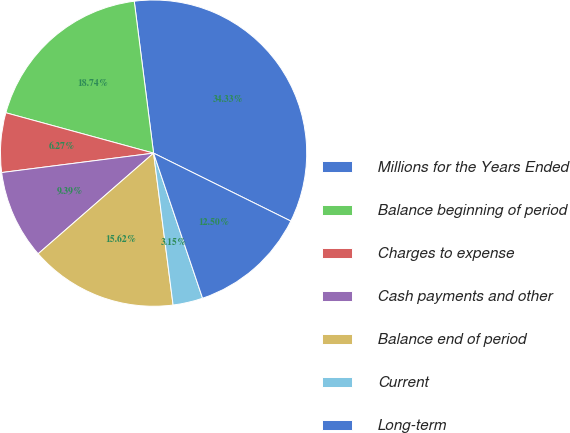<chart> <loc_0><loc_0><loc_500><loc_500><pie_chart><fcel>Millions for the Years Ended<fcel>Balance beginning of period<fcel>Charges to expense<fcel>Cash payments and other<fcel>Balance end of period<fcel>Current<fcel>Long-term<nl><fcel>34.33%<fcel>18.74%<fcel>6.27%<fcel>9.39%<fcel>15.62%<fcel>3.15%<fcel>12.5%<nl></chart> 